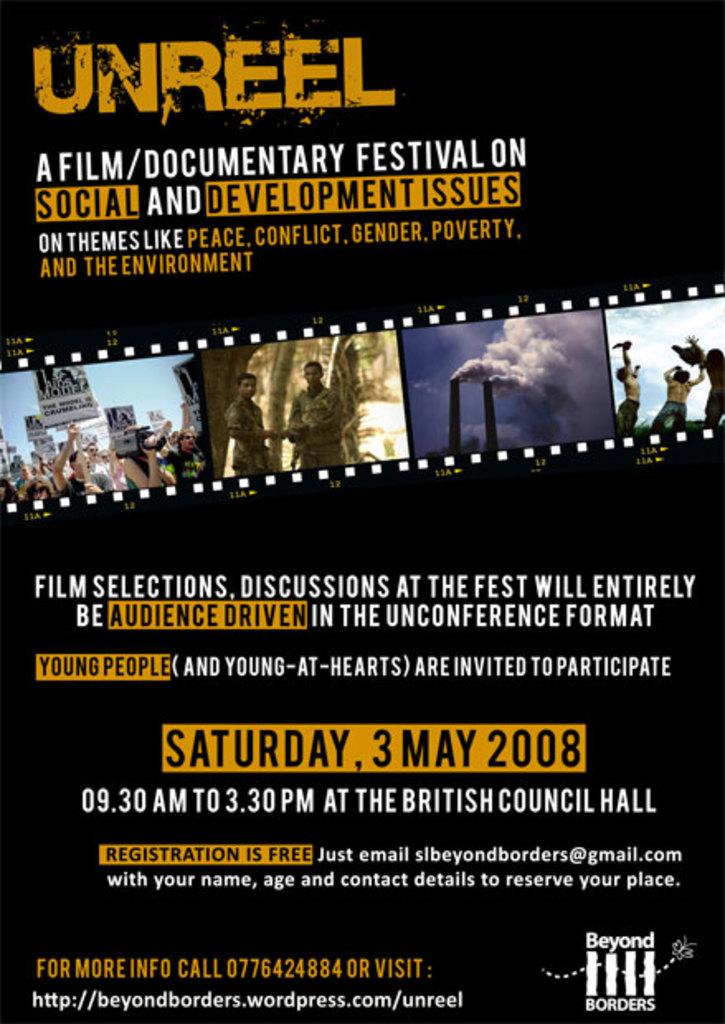What month is it currently?
Your answer should be compact. May. What date is the event?
Offer a very short reply. 3 may 2008. 